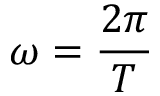Convert formula to latex. <formula><loc_0><loc_0><loc_500><loc_500>\omega = { \frac { 2 \pi } { T } }</formula> 